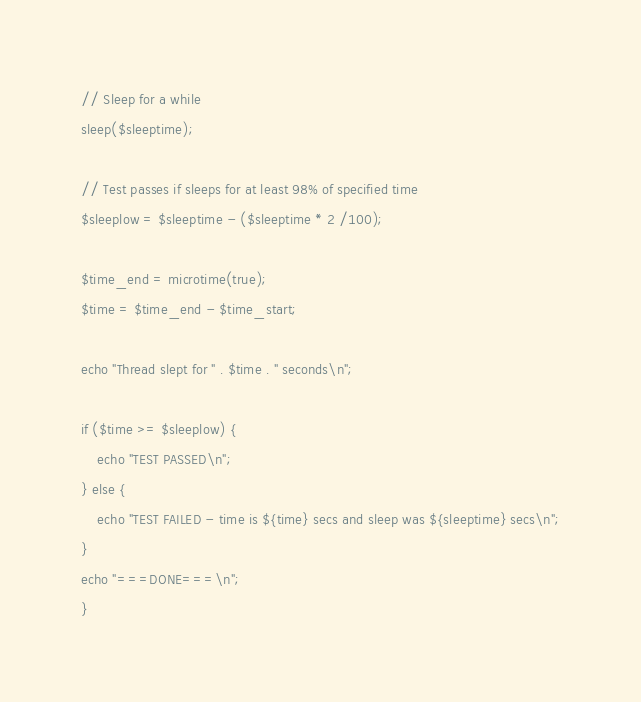Convert code to text. <code><loc_0><loc_0><loc_500><loc_500><_PHP_>// Sleep for a while
sleep($sleeptime);

// Test passes if sleeps for at least 98% of specified time
$sleeplow = $sleeptime - ($sleeptime * 2 /100);

$time_end = microtime(true);
$time = $time_end - $time_start;

echo "Thread slept for " . $time . " seconds\n";

if ($time >= $sleeplow) {
    echo "TEST PASSED\n";
} else {
    echo "TEST FAILED - time is ${time} secs and sleep was ${sleeptime} secs\n";
}
echo "===DONE===\n";
}
</code> 